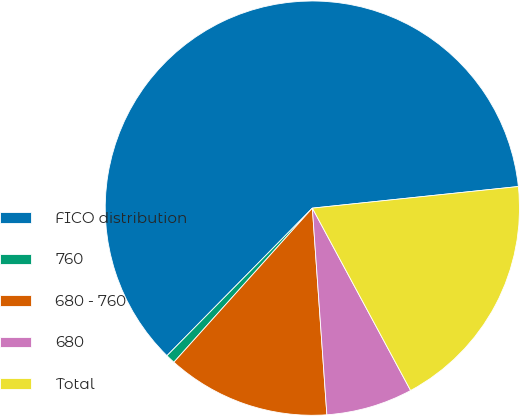<chart> <loc_0><loc_0><loc_500><loc_500><pie_chart><fcel>FICO distribution<fcel>760<fcel>680 - 760<fcel>680<fcel>Total<nl><fcel>60.96%<fcel>0.73%<fcel>12.77%<fcel>6.75%<fcel>18.8%<nl></chart> 